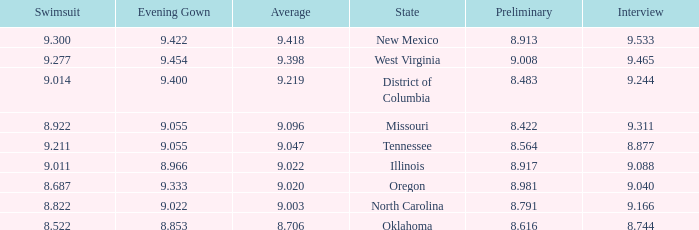Name the preliminary for north carolina 8.791. 